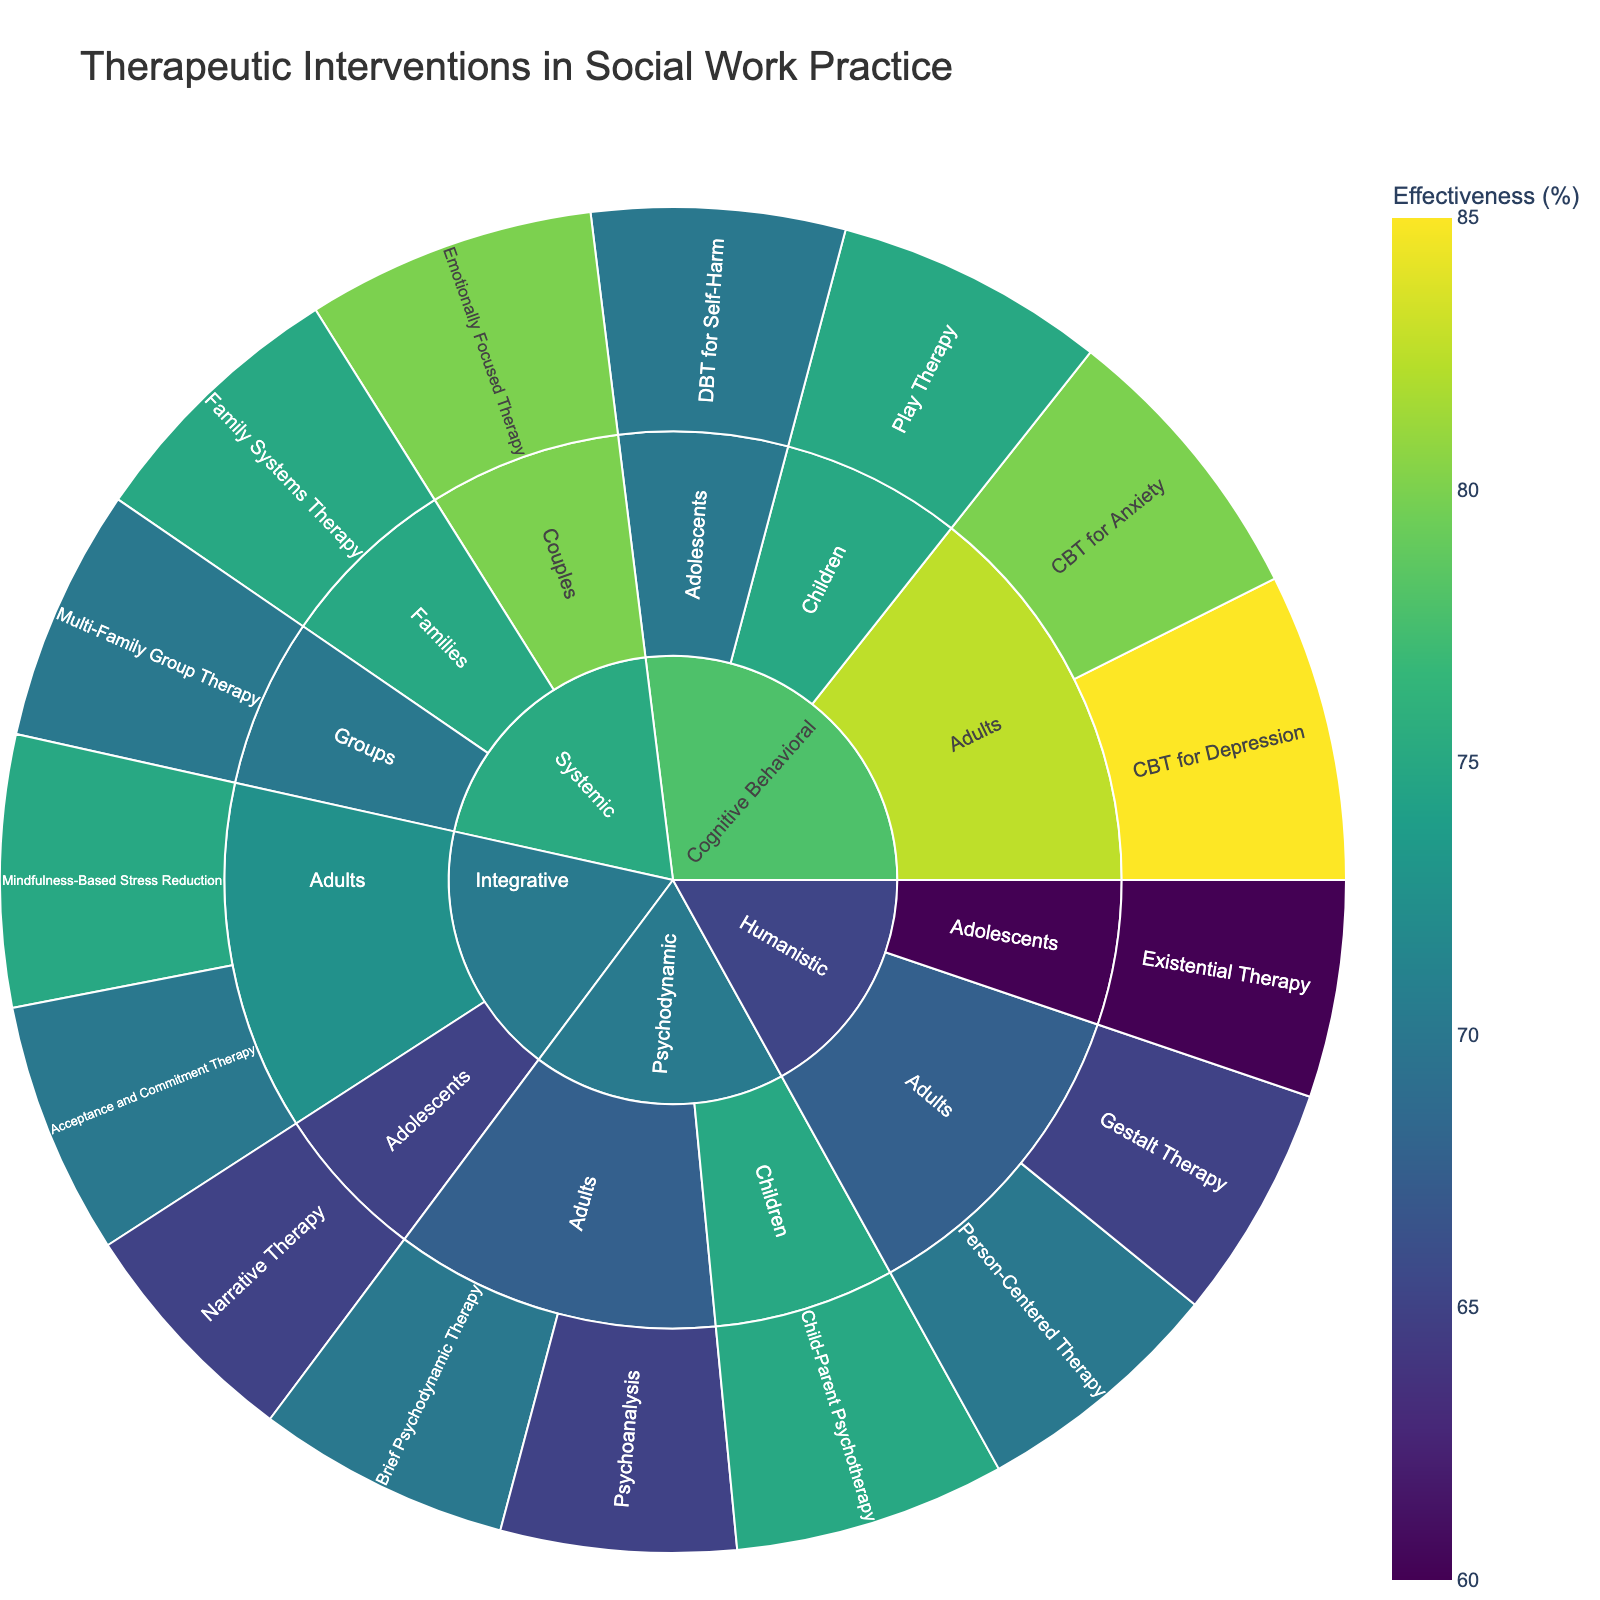What is the title of the sunburst plot? The title of the sunburst plot can be found at the top of the figure, which gives an overall description of what the plot represents.
Answer: Therapeutic Interventions in Social Work Practice What is the effectiveness rate of CBT for Depression for adults? Locate the Cognitive Behavioral approach, then drill down to the Adults population, and find CBT for Depression to see its effectiveness rate.
Answer: 85% Which therapeutic intervention for children has the highest effectiveness? Navigate through the children population segment in the sunburst plot and compare the effectiveness rates of each intervention listed under the various approaches.
Answer: Play Therapy How effective is Gestalt Therapy compared to Person-Centered Therapy for adults? Find Gestalt Therapy and Person-Centered Therapy under the Humanistic approach for the Adults population and compare their effectiveness rates.
Answer: Gestalt Therapy is 65% effective, whereas Person-Centered Therapy is 70% effective Which population group has the most diverse set of interventions across the different approaches? Look at each population group segment and count the number of different interventions listed under it.
Answer: Adults What is the difference in effectiveness between Family Systems Therapy and Emotionally Focused Therapy under the Systemic approach? Under the Systemic approach, locate Family Systems Therapy and Emotionally Focused Therapy and subtract their effectiveness rates.
Answer: 80% - 75% = 5% What is the average effectiveness rate of the interventions for adolescents? Identify all interventions listed for Adolescents across different approaches, sum up their effectiveness rates, and divide by the number of interventions. (DBT for Self-Harm: 70%, Existential Therapy: 60%, Narrative Therapy: 65%)
Answer: (70 + 60 + 65) / 3 = 65% Which therapeutic approach has the highest average effectiveness rate? Calculate the average effectiveness for each approach by summing the effectiveness rates of all its interventions and dividing by the number of interventions in that approach. Then compare these averages.
Answer: Cognitive Behavioral (average: 77.5%) How does the effectiveness of Psychoanalysis compare to Acceptance and Commitment Therapy? Locate Psychoanalysis under the Psychodynamic approach and Acceptance and Commitment Therapy under the Integrative approach, then compare their effectiveness rates.
Answer: Psychoanalysis (65%) has the same effectiveness rate as Acceptance and Commitment Therapy (70%) What is the effectiveness rate of Multi-Family Group Therapy? Locate the Multi-Family Group Therapy intervention under the Groups population within the Systemic approach and check its effectiveness rate.
Answer: 70% How many interventions have an effectiveness rate greater than 70%? Count all the interventions across different populations and approaches that have an effectiveness rate higher than 70%.
Answer: 7 